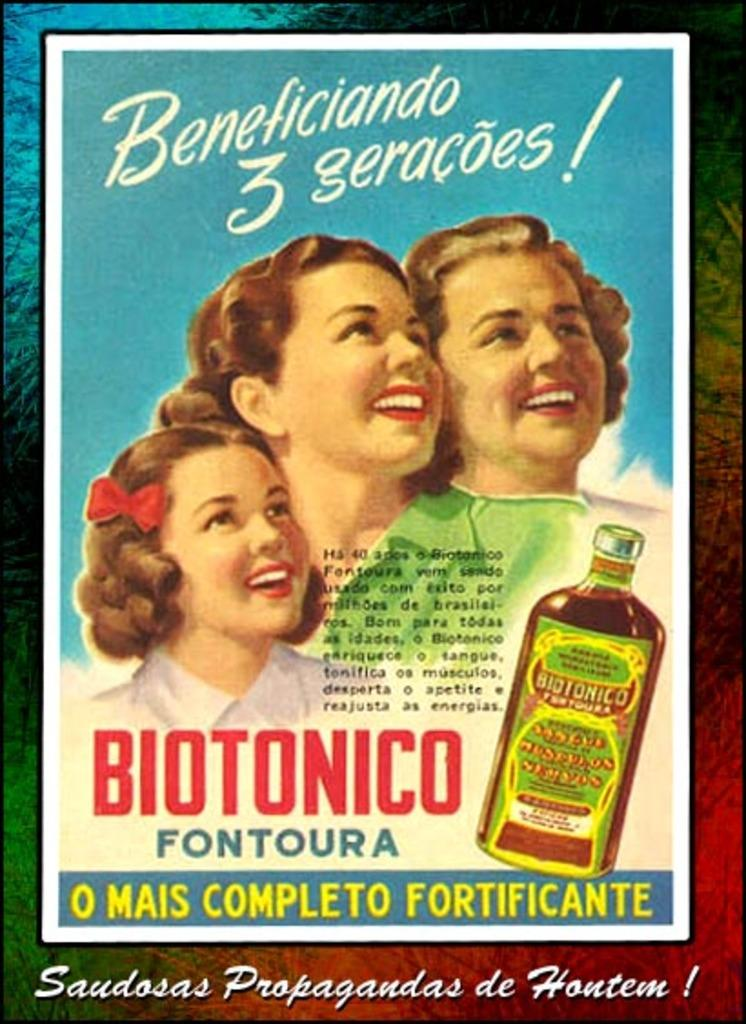<image>
Summarize the visual content of the image. An advertisement poster for a product called Biotonico 